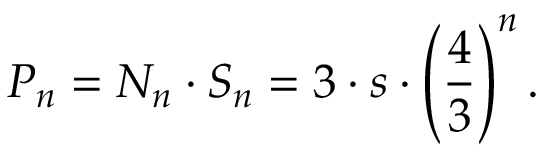<formula> <loc_0><loc_0><loc_500><loc_500>P _ { n } = N _ { n } \cdot S _ { n } = 3 \cdot s \cdot { \left ( { \frac { 4 } { 3 } } \right ) } ^ { n } \, .</formula> 